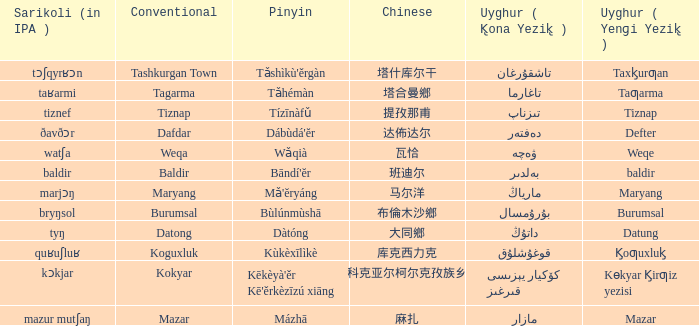Provide the uyghur equivalent for 瓦恰. ۋەچە. 